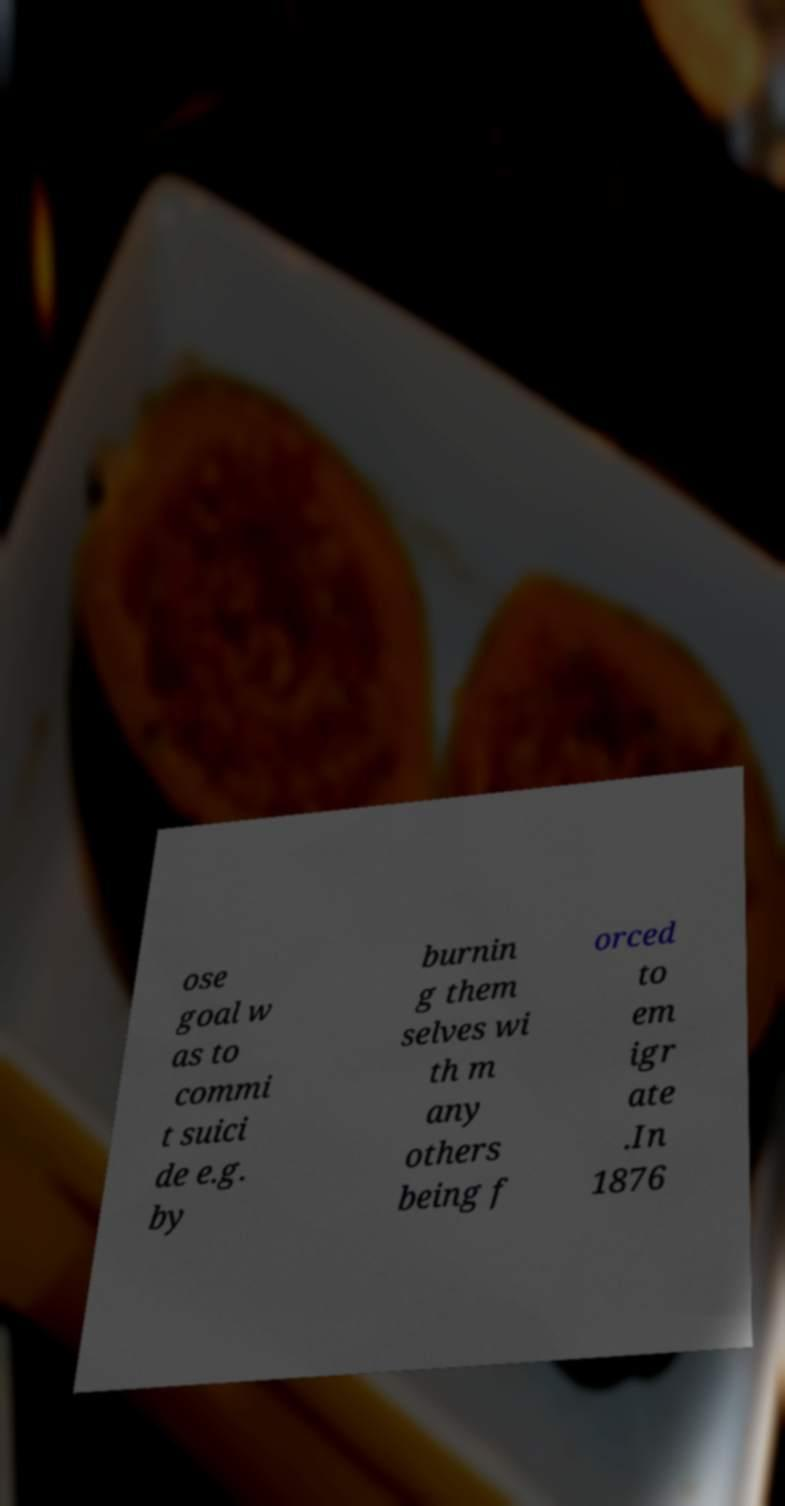Please read and relay the text visible in this image. What does it say? ose goal w as to commi t suici de e.g. by burnin g them selves wi th m any others being f orced to em igr ate .In 1876 